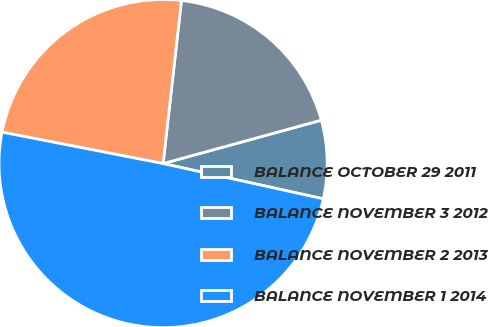Convert chart. <chart><loc_0><loc_0><loc_500><loc_500><pie_chart><fcel>BALANCE OCTOBER 29 2011<fcel>BALANCE NOVEMBER 3 2012<fcel>BALANCE NOVEMBER 2 2013<fcel>BALANCE NOVEMBER 1 2014<nl><fcel>7.71%<fcel>18.96%<fcel>23.72%<fcel>49.62%<nl></chart> 